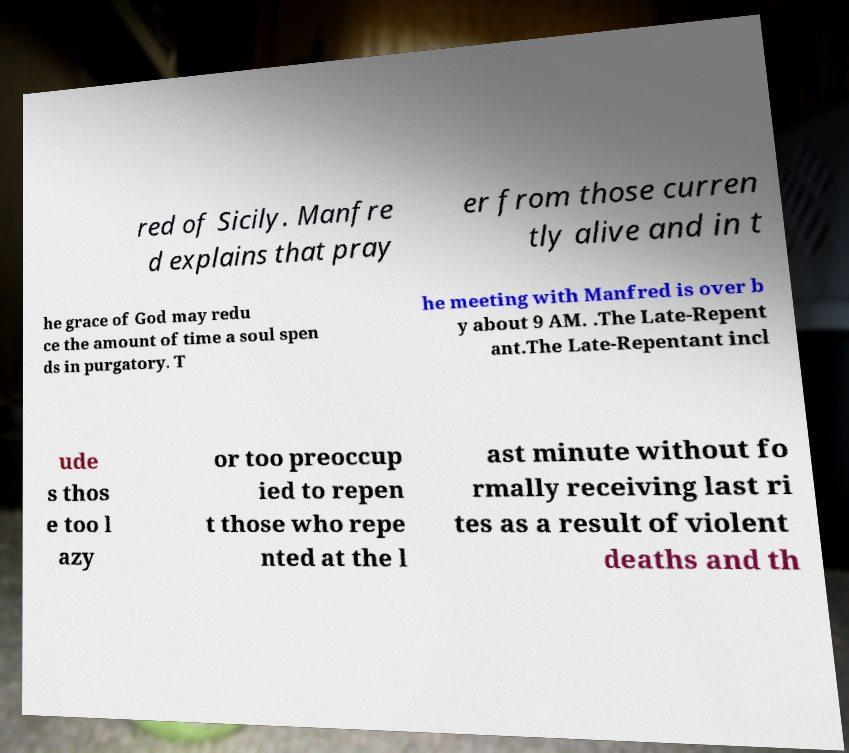Can you read and provide the text displayed in the image?This photo seems to have some interesting text. Can you extract and type it out for me? red of Sicily. Manfre d explains that pray er from those curren tly alive and in t he grace of God may redu ce the amount of time a soul spen ds in purgatory. T he meeting with Manfred is over b y about 9 AM. .The Late-Repent ant.The Late-Repentant incl ude s thos e too l azy or too preoccup ied to repen t those who repe nted at the l ast minute without fo rmally receiving last ri tes as a result of violent deaths and th 